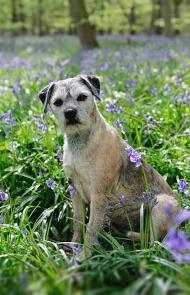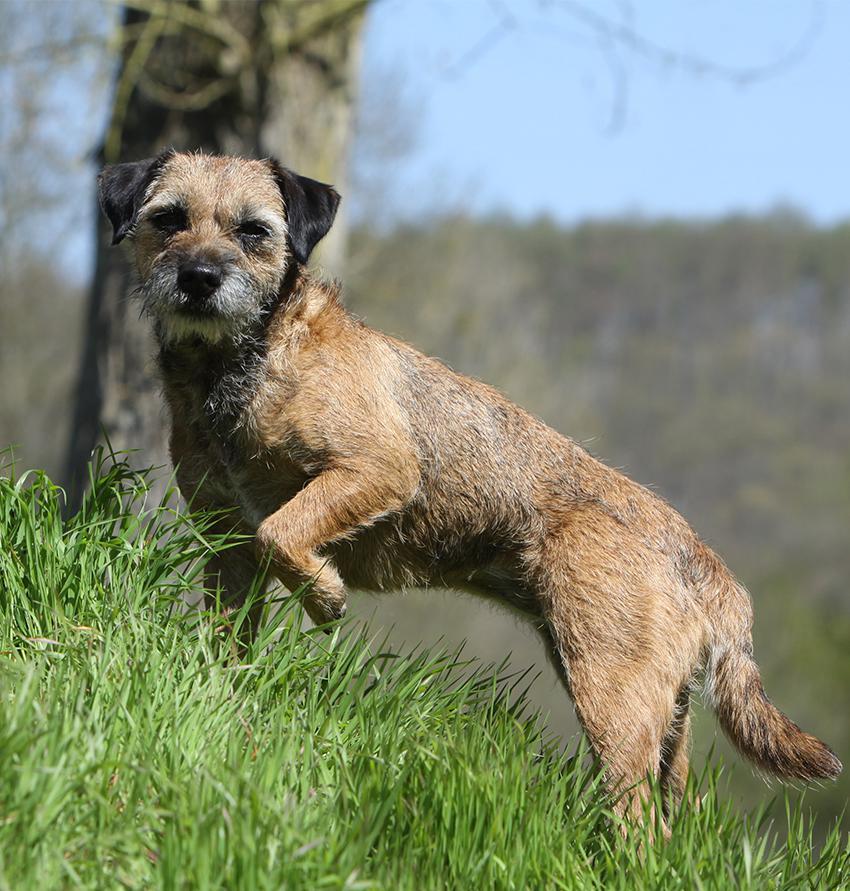The first image is the image on the left, the second image is the image on the right. Evaluate the accuracy of this statement regarding the images: "The left image features one dog in a sitting pose, and the right image shows a dog gazing at the camera and standing up on at least three feet.". Is it true? Answer yes or no. Yes. The first image is the image on the left, the second image is the image on the right. Given the left and right images, does the statement "A dog has a front paw off the ground." hold true? Answer yes or no. Yes. 